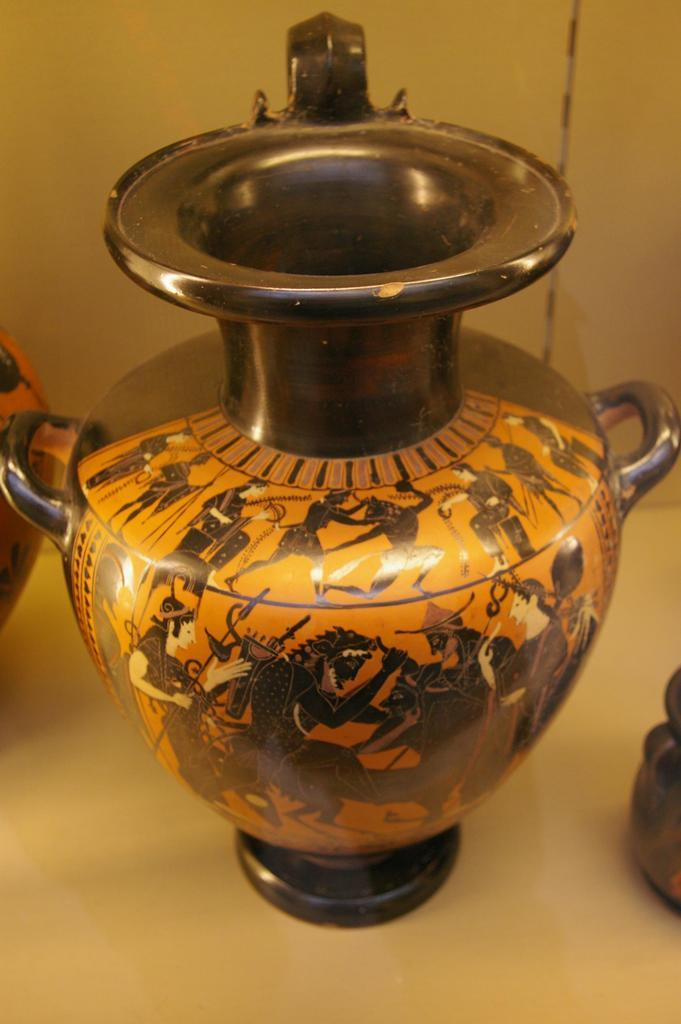What object is present in the image? There is a ceramic flower vase in the image. Where is the flower vase located? The flower vase is placed on a white surface. What can be observed about the design of the flower vase? The flower vase has a design on it. Can you see the father and the zebra in the image? There is no father or zebra present in the image; it only features a ceramic flower vase on a white surface. 